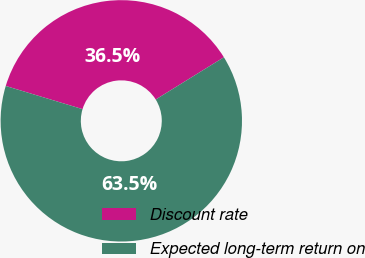Convert chart to OTSL. <chart><loc_0><loc_0><loc_500><loc_500><pie_chart><fcel>Discount rate<fcel>Expected long-term return on<nl><fcel>36.51%<fcel>63.49%<nl></chart> 